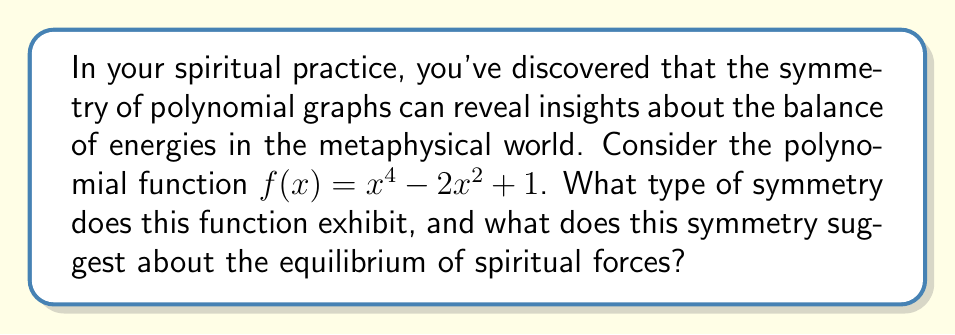Provide a solution to this math problem. To determine the symmetry of the polynomial function $f(x) = x^4 - 2x^2 + 1$, we need to analyze its behavior:

1. Even function test:
   Let's check if $f(-x) = f(x)$ for all $x$:
   $f(-x) = (-x)^4 - 2(-x)^2 + 1$
          $= x^4 - 2x^2 + 1$
          $= f(x)$

   Since $f(-x) = f(x)$, the function is even.

2. Graphical interpretation:
   An even function is symmetric about the y-axis. This means that for every point $(a, b)$ on the graph, the point $(-a, b)$ is also on the graph.

3. Polynomial structure:
   Notice that the function only contains even powers of $x$ (4, 2, and 0). This is a characteristic of even functions.

4. Metaphysical interpretation:
   In the context of spiritual energies, y-axis symmetry suggests a perfect balance between positive and negative forces. The left side of the y-axis (traditionally associated with the past or yin energies) perfectly mirrors the right side (future or yang energies).

5. Further analysis:
   The graph of this function is a W-shaped curve that touches the x-axis at two points and has a local maximum at the origin. This could be interpreted as representing two balanced low points of spiritual energy, with a central point of higher energy maintaining equilibrium.
Answer: Even symmetry (y-axis symmetry) 